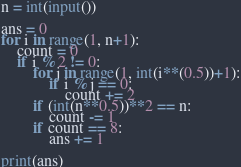Convert code to text. <code><loc_0><loc_0><loc_500><loc_500><_Python_>n = int(input())

ans = 0
for i in range(1, n+1):
    count = 0
    if i % 2 != 0:
        for j in range(1, int(i**(0.5))+1):
            if i % j == 0:
                count += 2
        if (int(n**0.5))**2 == n:
            count -= 1
        if count == 8:
            ans += 1

print(ans)

</code> 